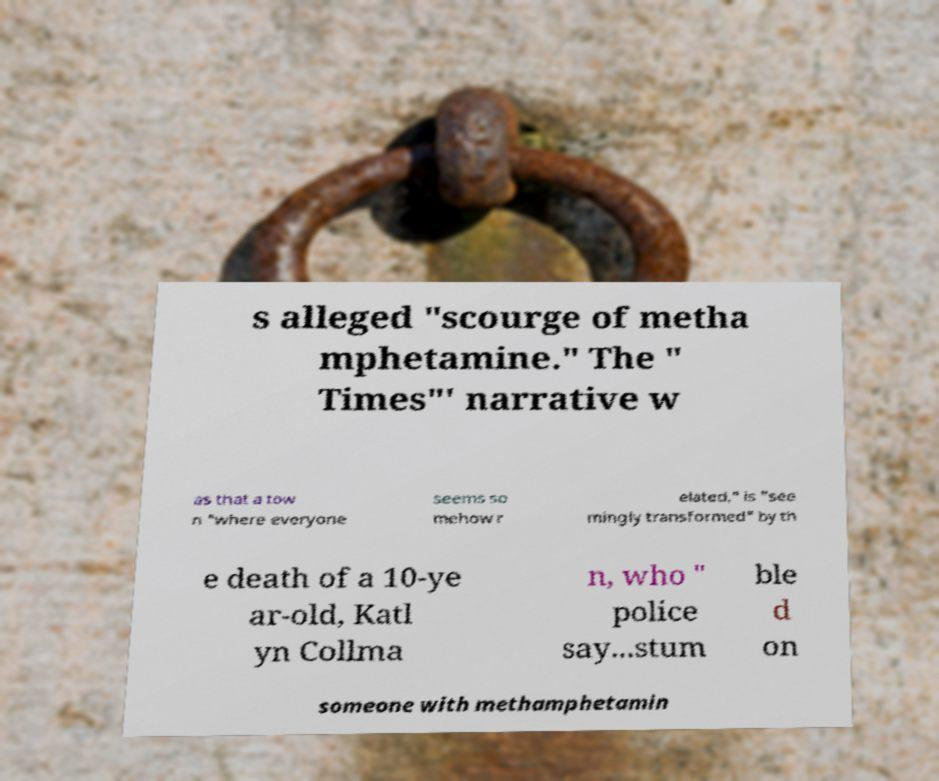Could you extract and type out the text from this image? s alleged "scourge of metha mphetamine." The " Times"' narrative w as that a tow n "where everyone seems so mehow r elated," is "see mingly transformed" by th e death of a 10-ye ar-old, Katl yn Collma n, who " police say...stum ble d on someone with methamphetamin 